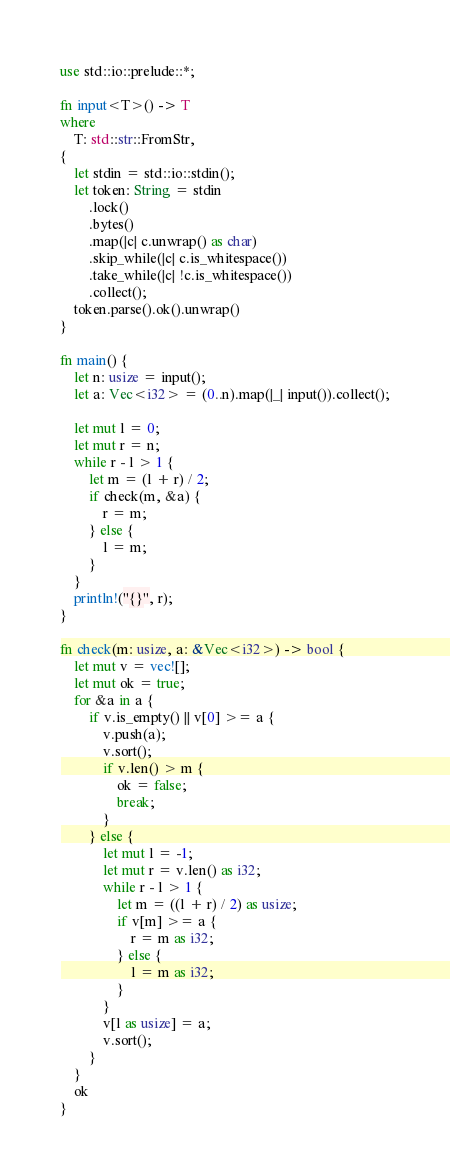Convert code to text. <code><loc_0><loc_0><loc_500><loc_500><_Rust_>use std::io::prelude::*;

fn input<T>() -> T
where
    T: std::str::FromStr,
{
    let stdin = std::io::stdin();
    let token: String = stdin
        .lock()
        .bytes()
        .map(|c| c.unwrap() as char)
        .skip_while(|c| c.is_whitespace())
        .take_while(|c| !c.is_whitespace())
        .collect();
    token.parse().ok().unwrap()
}

fn main() {
    let n: usize = input();
    let a: Vec<i32> = (0..n).map(|_| input()).collect();

    let mut l = 0;
    let mut r = n;
    while r - l > 1 {
        let m = (l + r) / 2;
        if check(m, &a) {
            r = m;
        } else {
            l = m;
        }
    }
    println!("{}", r);
}

fn check(m: usize, a: &Vec<i32>) -> bool {
    let mut v = vec![];
    let mut ok = true;
    for &a in a {
        if v.is_empty() || v[0] >= a {
            v.push(a);
            v.sort();
            if v.len() > m {
                ok = false;
                break;
            }
        } else {
            let mut l = -1;
            let mut r = v.len() as i32;
            while r - l > 1 {
                let m = ((l + r) / 2) as usize;
                if v[m] >= a {
                    r = m as i32;
                } else {
                    l = m as i32;
                }
            }
            v[l as usize] = a;
            v.sort();
        }
    }
    ok
}
</code> 